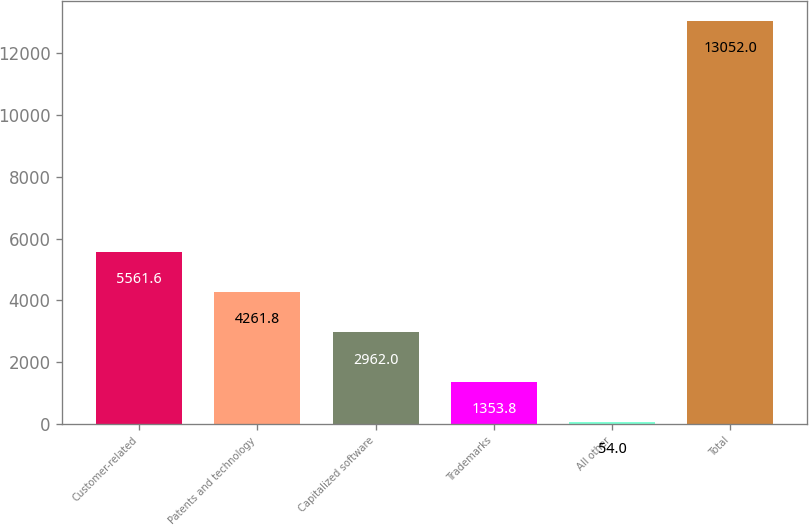Convert chart to OTSL. <chart><loc_0><loc_0><loc_500><loc_500><bar_chart><fcel>Customer-related<fcel>Patents and technology<fcel>Capitalized software<fcel>Trademarks<fcel>All other<fcel>Total<nl><fcel>5561.6<fcel>4261.8<fcel>2962<fcel>1353.8<fcel>54<fcel>13052<nl></chart> 